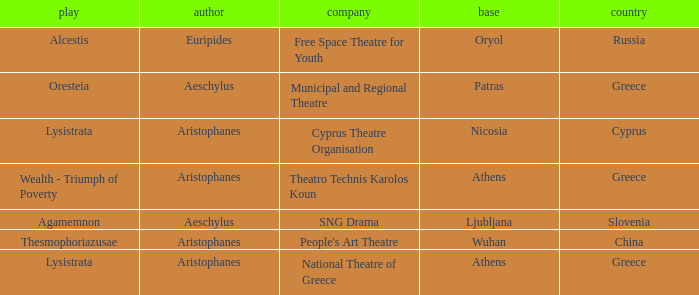What is the organization when the territory is greece and the author is aeschylus? Municipal and Regional Theatre. 